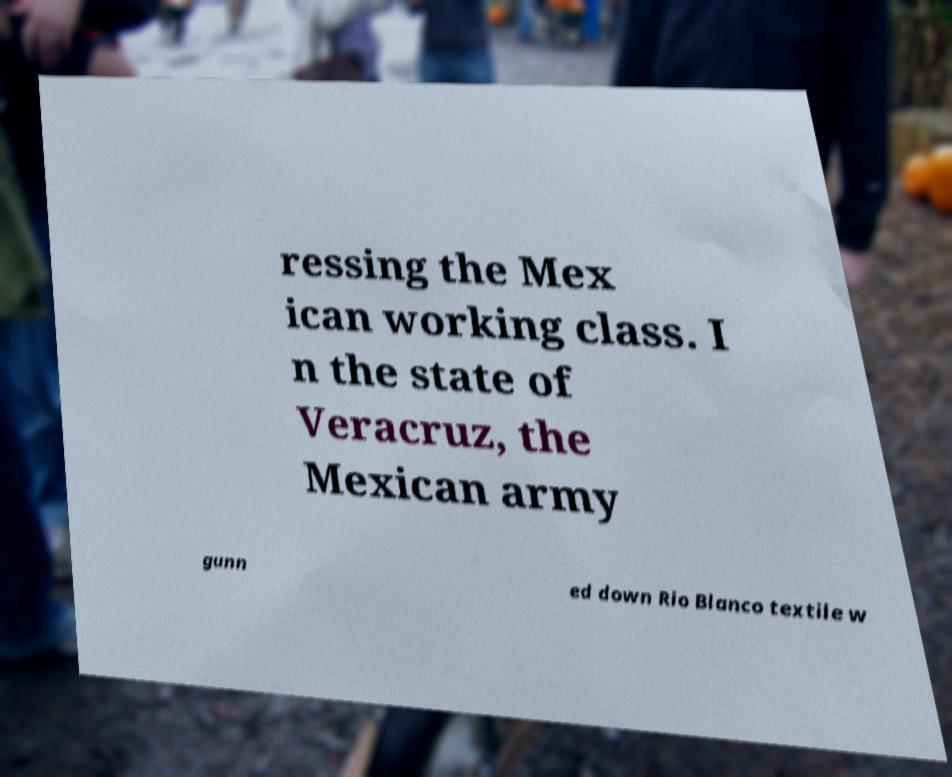Please identify and transcribe the text found in this image. ressing the Mex ican working class. I n the state of Veracruz, the Mexican army gunn ed down Rio Blanco textile w 